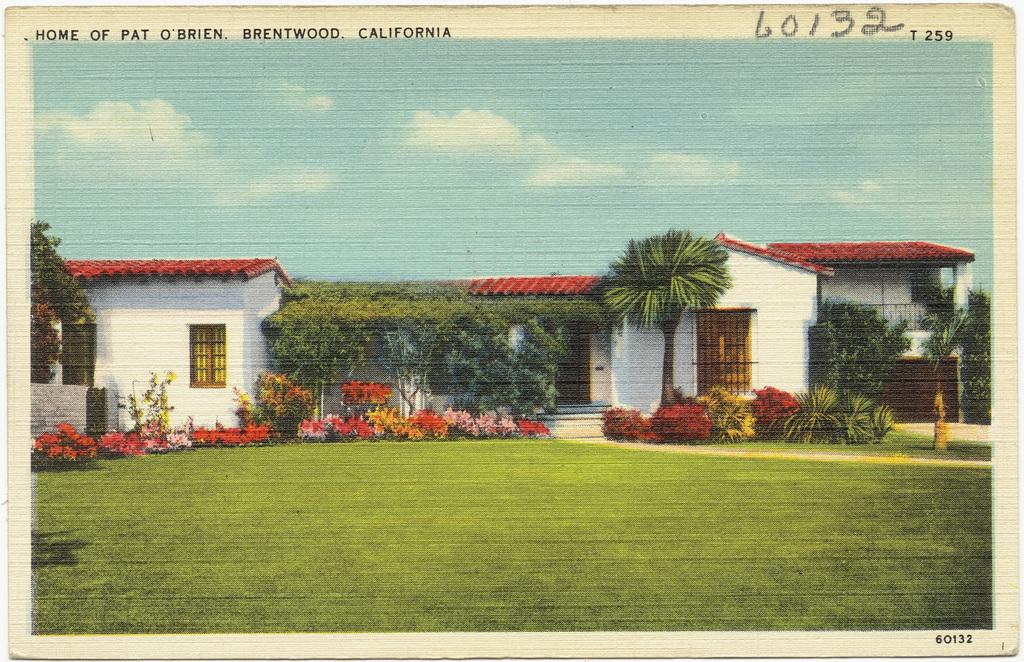What type of structure is present in the image? There is a house in the image. What other natural elements can be seen in the image? There are trees in the image. What is visible in the background of the image? The sky is visible in the background of the image. What type of book is the house reading in the image? There is no book present in the image, and houses do not read books. 